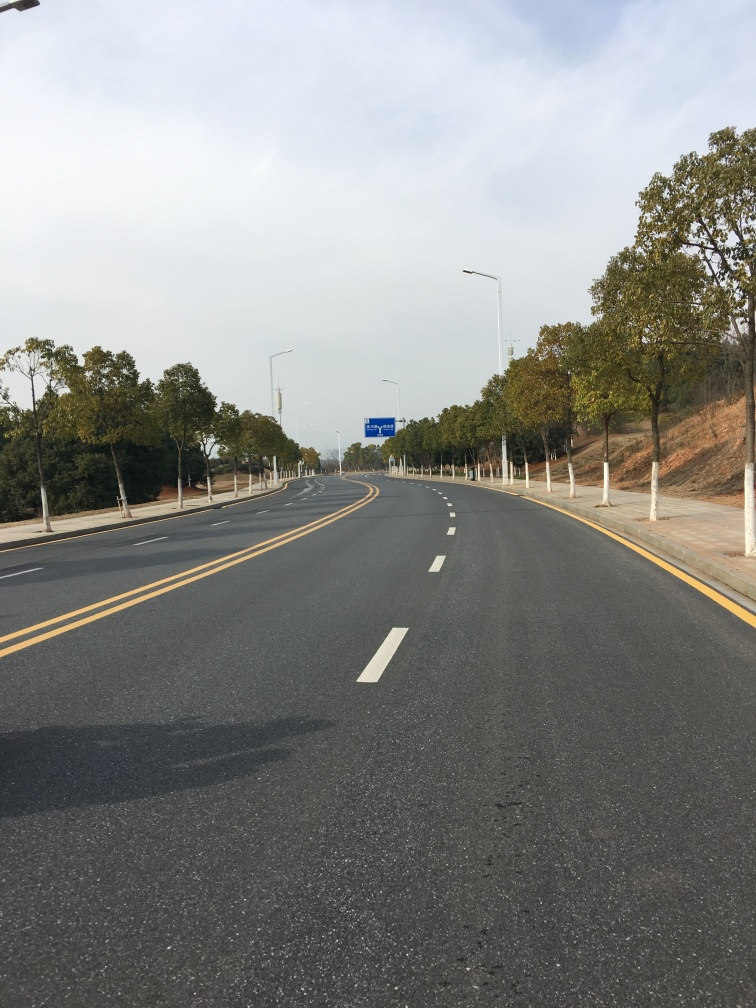What is the color like in the image? The image showcases a road during daylight with a mostly clear sky. The colors are natural and well-lit, with the road being a shade of dark gray, complemented by the yellow road markings. The surrounding foliage has hues of green and brown, indicating a natural, possibly autumnal, setting. The overall color palette is bright and clear, with no signs of dullness. 